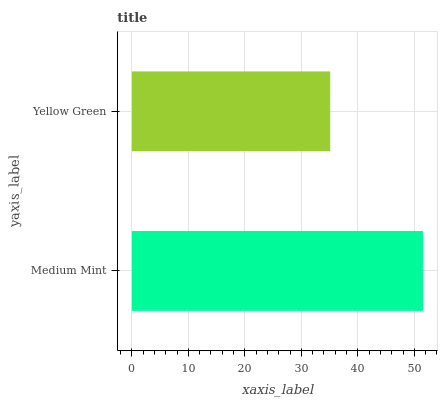Is Yellow Green the minimum?
Answer yes or no. Yes. Is Medium Mint the maximum?
Answer yes or no. Yes. Is Yellow Green the maximum?
Answer yes or no. No. Is Medium Mint greater than Yellow Green?
Answer yes or no. Yes. Is Yellow Green less than Medium Mint?
Answer yes or no. Yes. Is Yellow Green greater than Medium Mint?
Answer yes or no. No. Is Medium Mint less than Yellow Green?
Answer yes or no. No. Is Medium Mint the high median?
Answer yes or no. Yes. Is Yellow Green the low median?
Answer yes or no. Yes. Is Yellow Green the high median?
Answer yes or no. No. Is Medium Mint the low median?
Answer yes or no. No. 